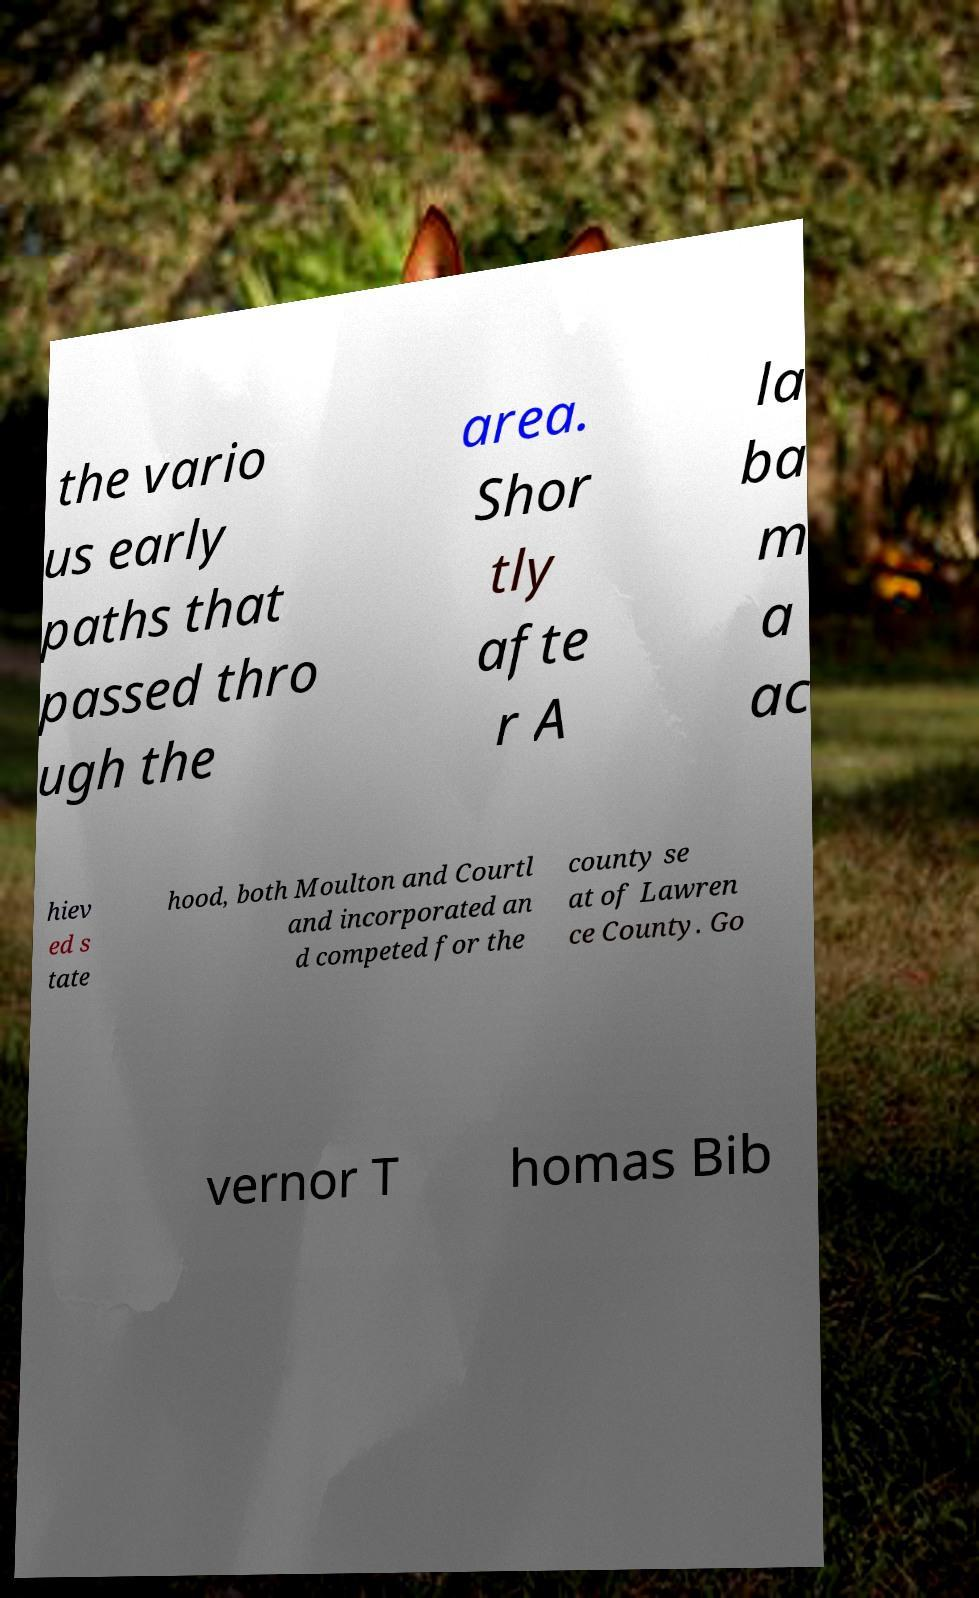I need the written content from this picture converted into text. Can you do that? the vario us early paths that passed thro ugh the area. Shor tly afte r A la ba m a ac hiev ed s tate hood, both Moulton and Courtl and incorporated an d competed for the county se at of Lawren ce County. Go vernor T homas Bib 